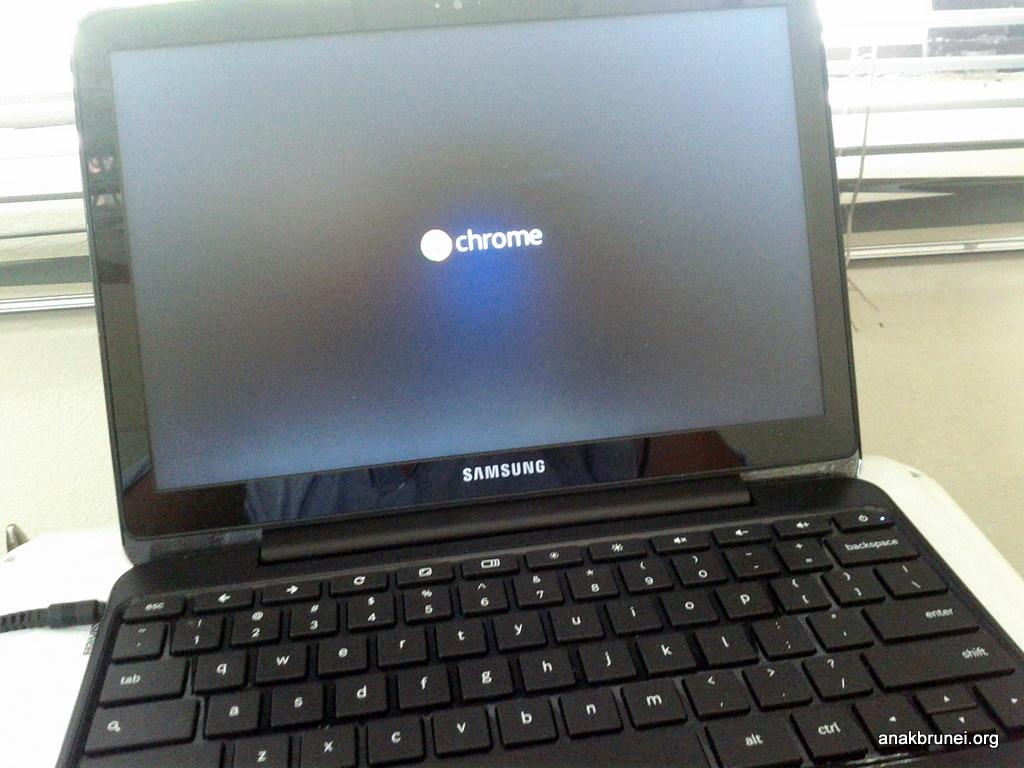Who is the maker of the laptop?
Your response must be concise. Samsung. What os is on the laptop?
Give a very brief answer. Chrome. 